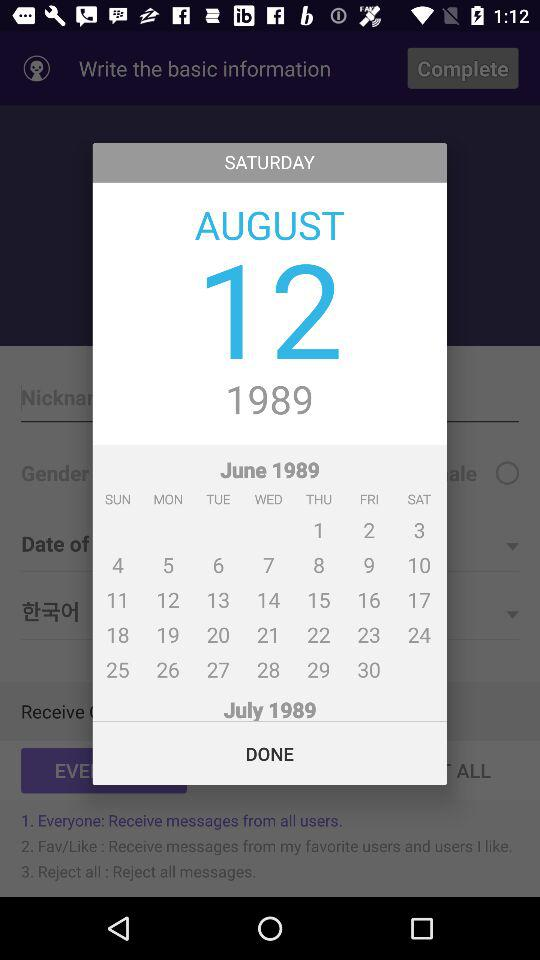What is the day on the 12th of August? The day on the 12th of August is Saturday. 